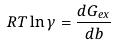Convert formula to latex. <formula><loc_0><loc_0><loc_500><loc_500>R T \ln \gamma = \frac { d G _ { e x } } { d b }</formula> 